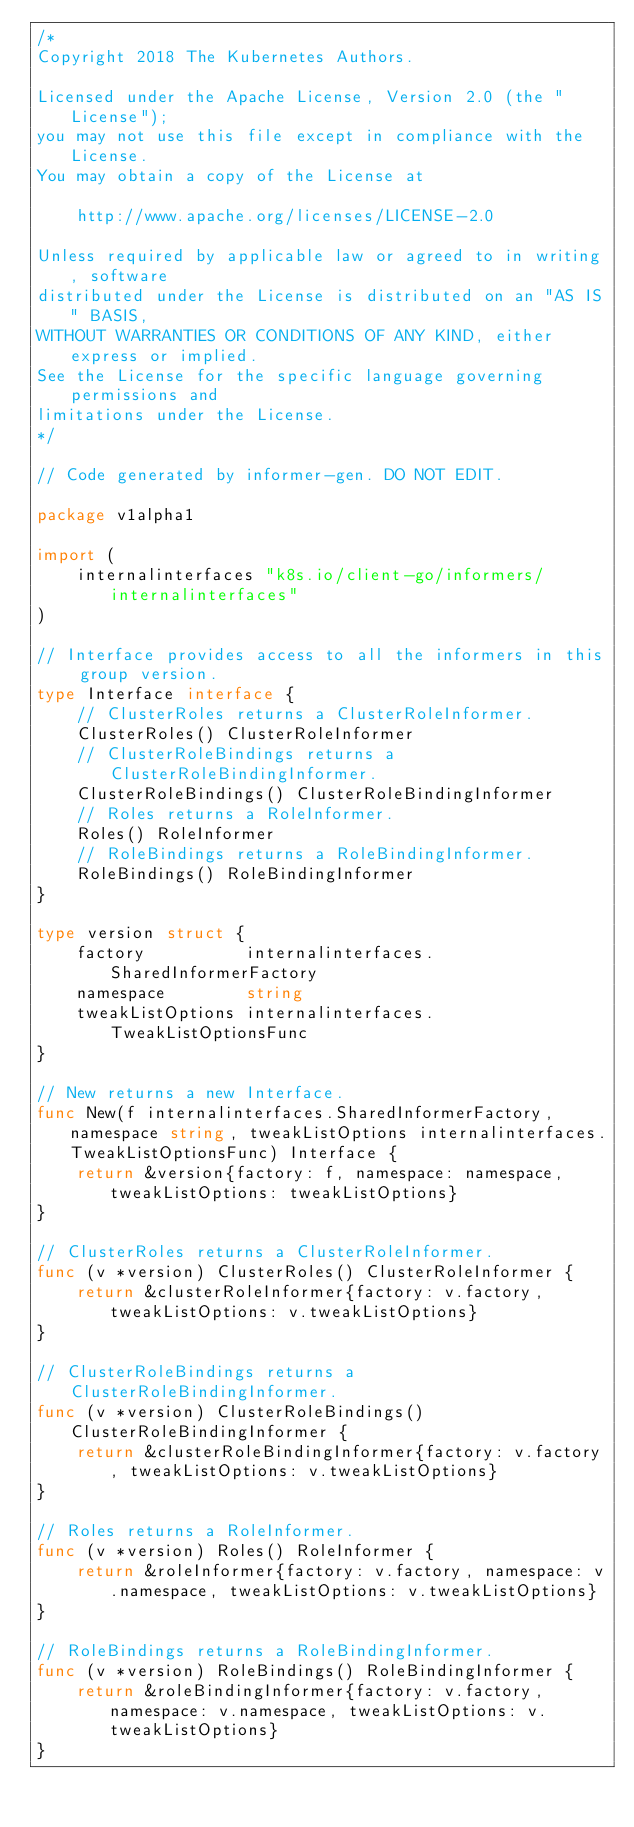Convert code to text. <code><loc_0><loc_0><loc_500><loc_500><_Go_>/*
Copyright 2018 The Kubernetes Authors.

Licensed under the Apache License, Version 2.0 (the "License");
you may not use this file except in compliance with the License.
You may obtain a copy of the License at

    http://www.apache.org/licenses/LICENSE-2.0

Unless required by applicable law or agreed to in writing, software
distributed under the License is distributed on an "AS IS" BASIS,
WITHOUT WARRANTIES OR CONDITIONS OF ANY KIND, either express or implied.
See the License for the specific language governing permissions and
limitations under the License.
*/

// Code generated by informer-gen. DO NOT EDIT.

package v1alpha1

import (
	internalinterfaces "k8s.io/client-go/informers/internalinterfaces"
)

// Interface provides access to all the informers in this group version.
type Interface interface {
	// ClusterRoles returns a ClusterRoleInformer.
	ClusterRoles() ClusterRoleInformer
	// ClusterRoleBindings returns a ClusterRoleBindingInformer.
	ClusterRoleBindings() ClusterRoleBindingInformer
	// Roles returns a RoleInformer.
	Roles() RoleInformer
	// RoleBindings returns a RoleBindingInformer.
	RoleBindings() RoleBindingInformer
}

type version struct {
	factory          internalinterfaces.SharedInformerFactory
	namespace        string
	tweakListOptions internalinterfaces.TweakListOptionsFunc
}

// New returns a new Interface.
func New(f internalinterfaces.SharedInformerFactory, namespace string, tweakListOptions internalinterfaces.TweakListOptionsFunc) Interface {
	return &version{factory: f, namespace: namespace, tweakListOptions: tweakListOptions}
}

// ClusterRoles returns a ClusterRoleInformer.
func (v *version) ClusterRoles() ClusterRoleInformer {
	return &clusterRoleInformer{factory: v.factory, tweakListOptions: v.tweakListOptions}
}

// ClusterRoleBindings returns a ClusterRoleBindingInformer.
func (v *version) ClusterRoleBindings() ClusterRoleBindingInformer {
	return &clusterRoleBindingInformer{factory: v.factory, tweakListOptions: v.tweakListOptions}
}

// Roles returns a RoleInformer.
func (v *version) Roles() RoleInformer {
	return &roleInformer{factory: v.factory, namespace: v.namespace, tweakListOptions: v.tweakListOptions}
}

// RoleBindings returns a RoleBindingInformer.
func (v *version) RoleBindings() RoleBindingInformer {
	return &roleBindingInformer{factory: v.factory, namespace: v.namespace, tweakListOptions: v.tweakListOptions}
}
</code> 